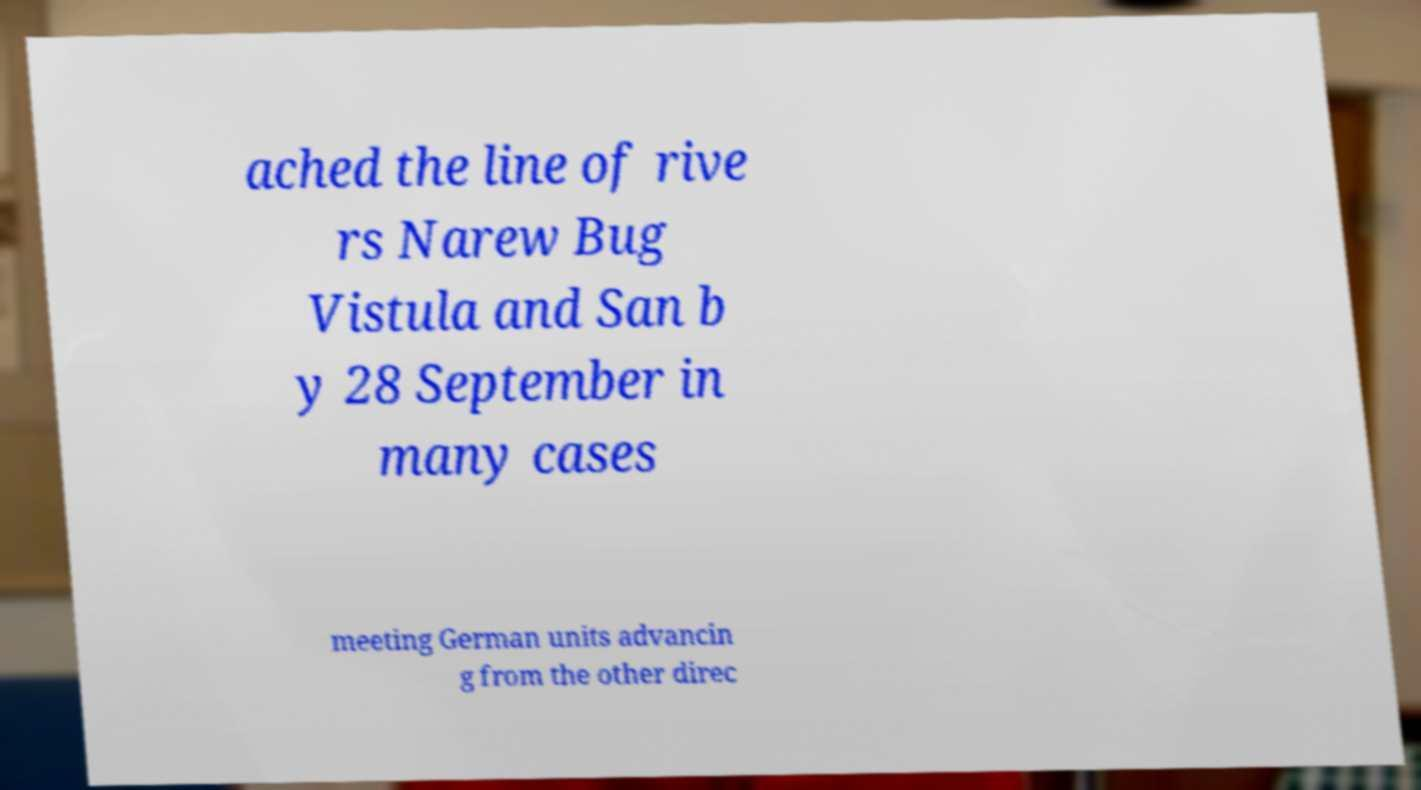Could you assist in decoding the text presented in this image and type it out clearly? ached the line of rive rs Narew Bug Vistula and San b y 28 September in many cases meeting German units advancin g from the other direc 